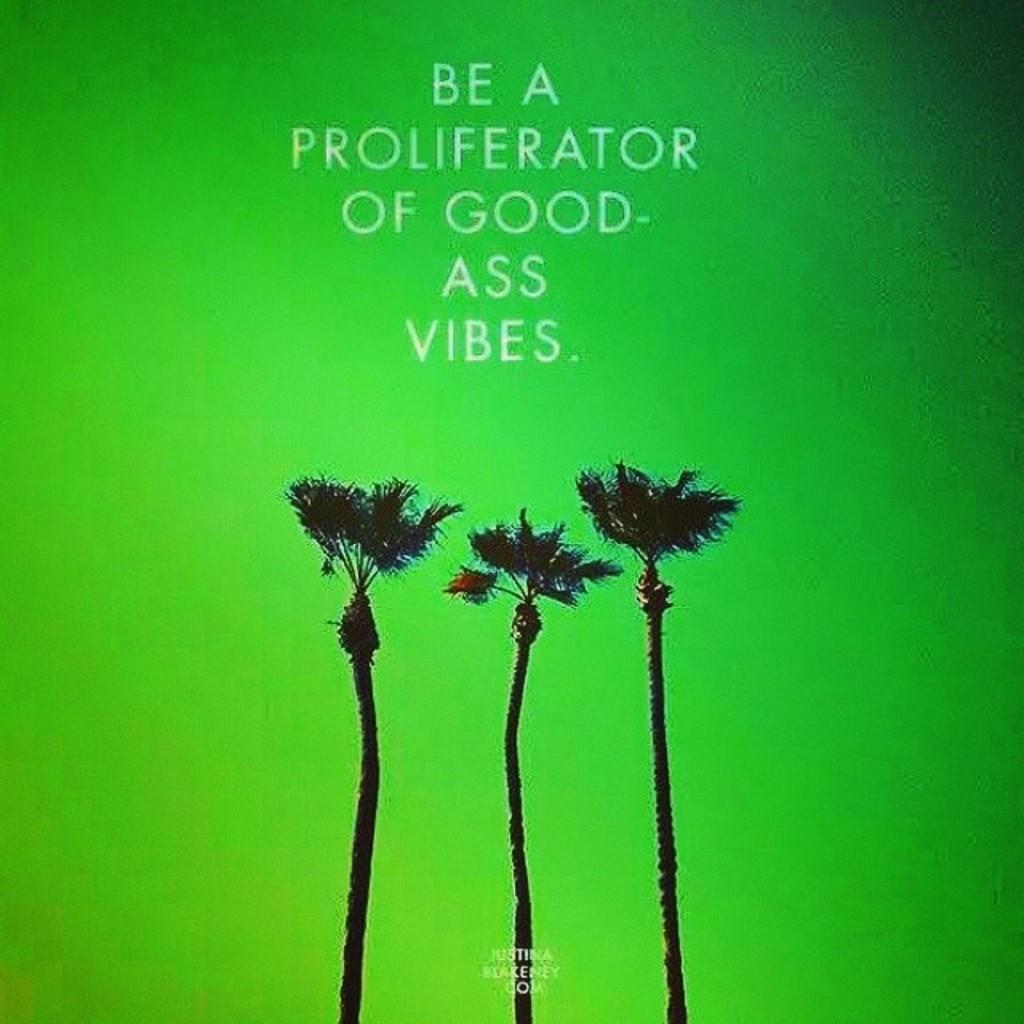What type of vegetation can be seen in the image? There are trees in the image. What else is present in the image besides the trees? There is text visible in the image. What is the color of the background in the image? The background of the image has a green color. Can you describe the condition of the airplane in the image? There is no airplane present in the image, so it is not possible to describe its condition. 